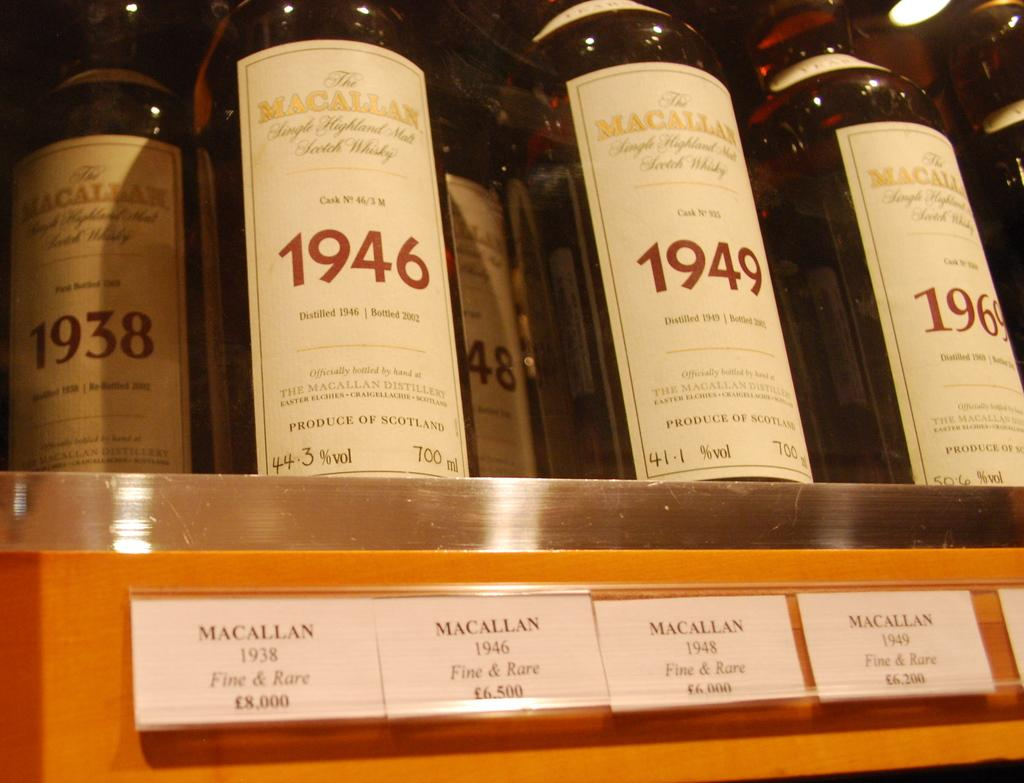Provide a one-sentence caption for the provided image. A row of vintage Macallan wines sit in a row inside of a display case. 